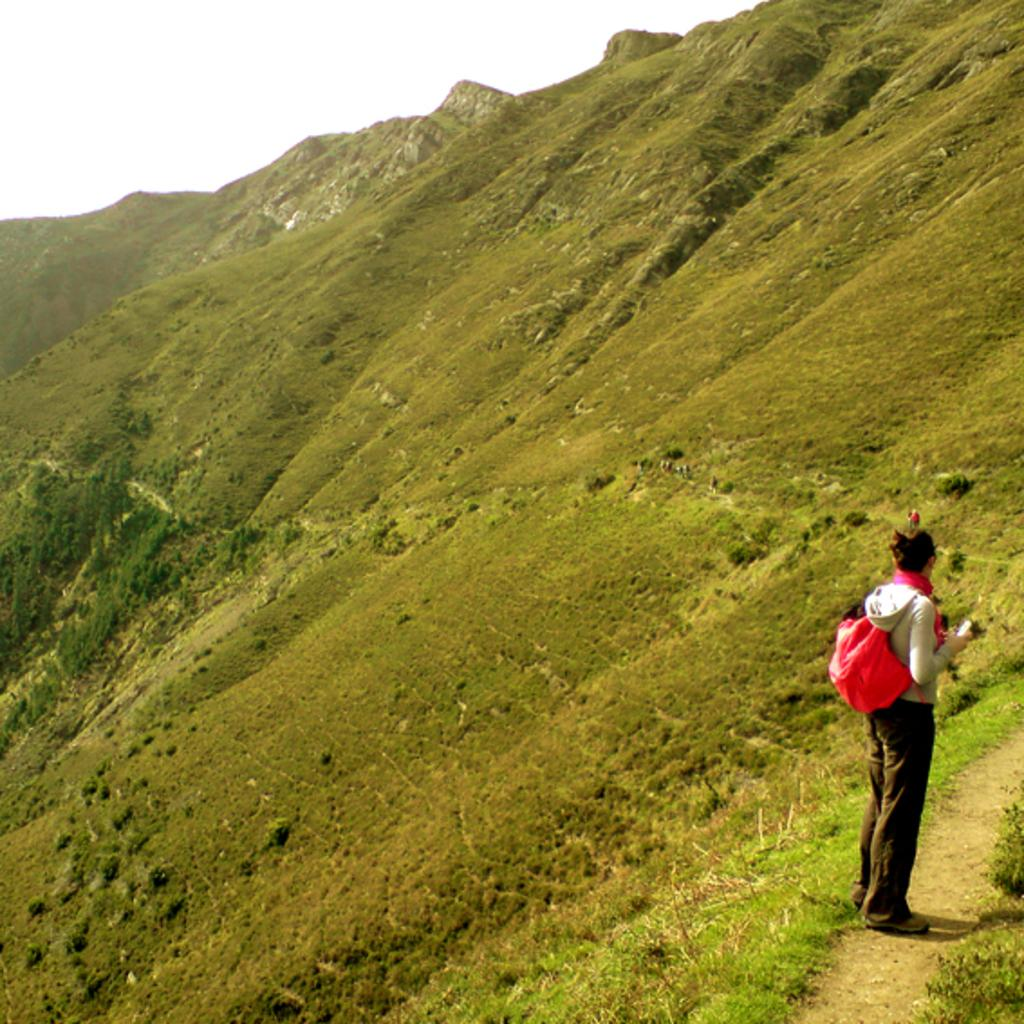Who is in the image? There is a person in the image. What is the person carrying on their back? The person is wearing a backpack. What is the person holding in their hand? The person is holding a mobile. What type of vegetation can be seen in the image? There are plants and grass visible in the image. What type of landscape is visible in the background? There are mountains in the image. What part of the natural environment is visible in the image? The sky is visible in the image. What type of drug can be seen in the person's hand in the image? There is no drug present in the image; the person is holding a mobile. What type of playground equipment can be seen in the image? There is no playground equipment present in the image. 